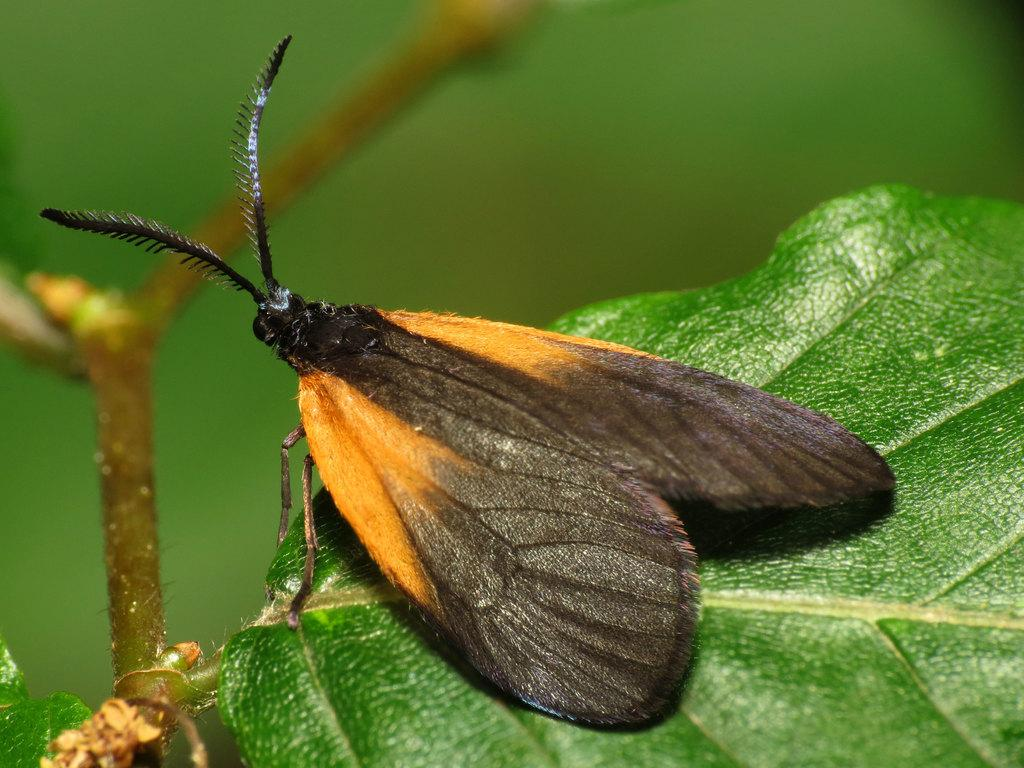What is present on the leaf in the image? There is an insect on the leaf in the image. What colors can be seen on the insect? The insect has orange and black colors. What color is the leaf in the image? The leaf has a green color. Is the insect wearing a mask in the image? No, the insect is not wearing a mask in the image. How does the insect say good-bye to the leaf in the image? The insect does not say good-bye to the leaf in the image, as insects do not communicate in this way. 